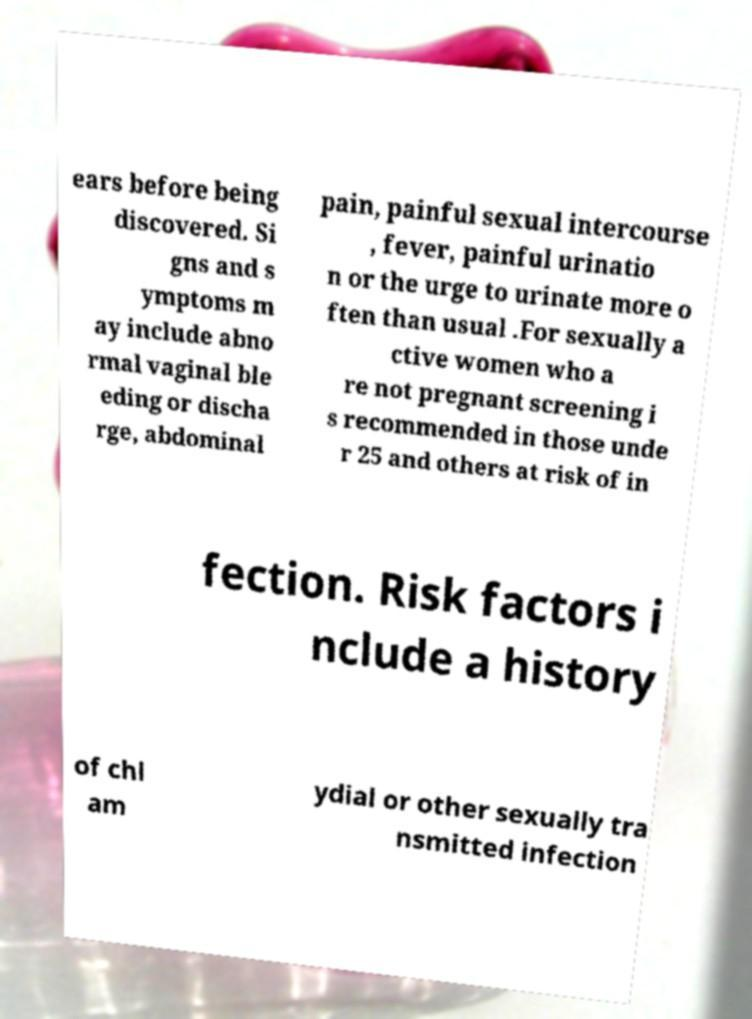What messages or text are displayed in this image? I need them in a readable, typed format. ears before being discovered. Si gns and s ymptoms m ay include abno rmal vaginal ble eding or discha rge, abdominal pain, painful sexual intercourse , fever, painful urinatio n or the urge to urinate more o ften than usual .For sexually a ctive women who a re not pregnant screening i s recommended in those unde r 25 and others at risk of in fection. Risk factors i nclude a history of chl am ydial or other sexually tra nsmitted infection 